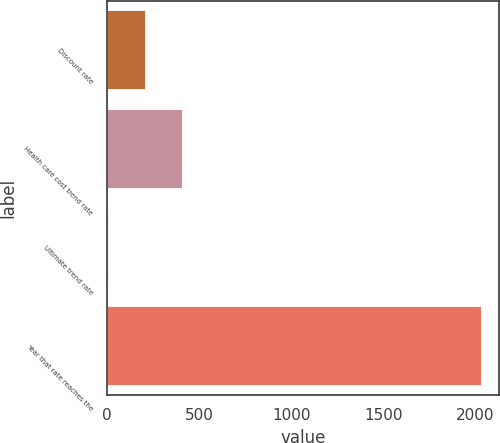<chart> <loc_0><loc_0><loc_500><loc_500><bar_chart><fcel>Discount rate<fcel>Health care cost trend rate<fcel>Ultimate trend rate<fcel>Year that rate reaches the<nl><fcel>207.28<fcel>409.69<fcel>4.87<fcel>2029<nl></chart> 